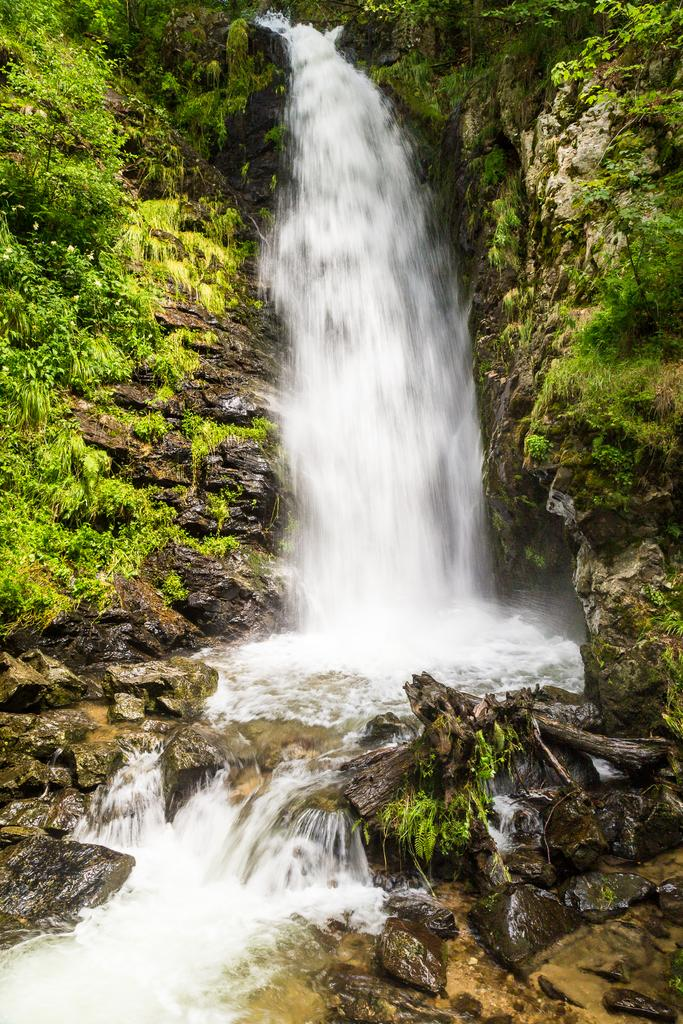What natural feature is the main subject of the image? There is a waterfall in the image. What other geographical features can be seen in the image? There are mountains and trees in the image. What type of clover can be found growing near the waterfall in the image? There is no clover present in the image; it focuses on the waterfall, mountains, and trees. 